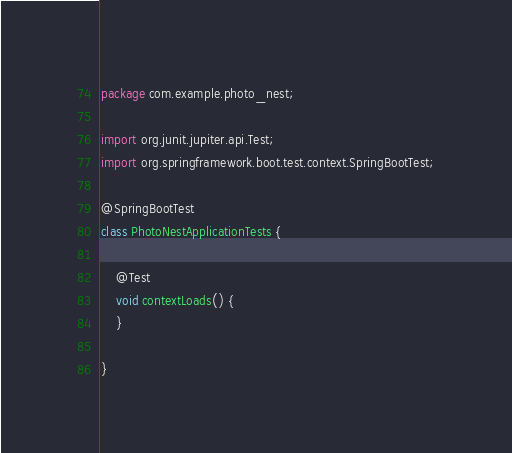Convert code to text. <code><loc_0><loc_0><loc_500><loc_500><_Java_>package com.example.photo_nest;

import org.junit.jupiter.api.Test;
import org.springframework.boot.test.context.SpringBootTest;

@SpringBootTest
class PhotoNestApplicationTests {

    @Test
    void contextLoads() {
    }

}
</code> 